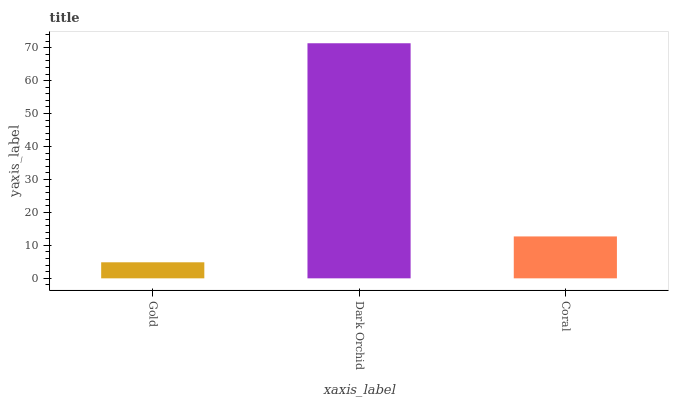Is Gold the minimum?
Answer yes or no. Yes. Is Dark Orchid the maximum?
Answer yes or no. Yes. Is Coral the minimum?
Answer yes or no. No. Is Coral the maximum?
Answer yes or no. No. Is Dark Orchid greater than Coral?
Answer yes or no. Yes. Is Coral less than Dark Orchid?
Answer yes or no. Yes. Is Coral greater than Dark Orchid?
Answer yes or no. No. Is Dark Orchid less than Coral?
Answer yes or no. No. Is Coral the high median?
Answer yes or no. Yes. Is Coral the low median?
Answer yes or no. Yes. Is Dark Orchid the high median?
Answer yes or no. No. Is Dark Orchid the low median?
Answer yes or no. No. 